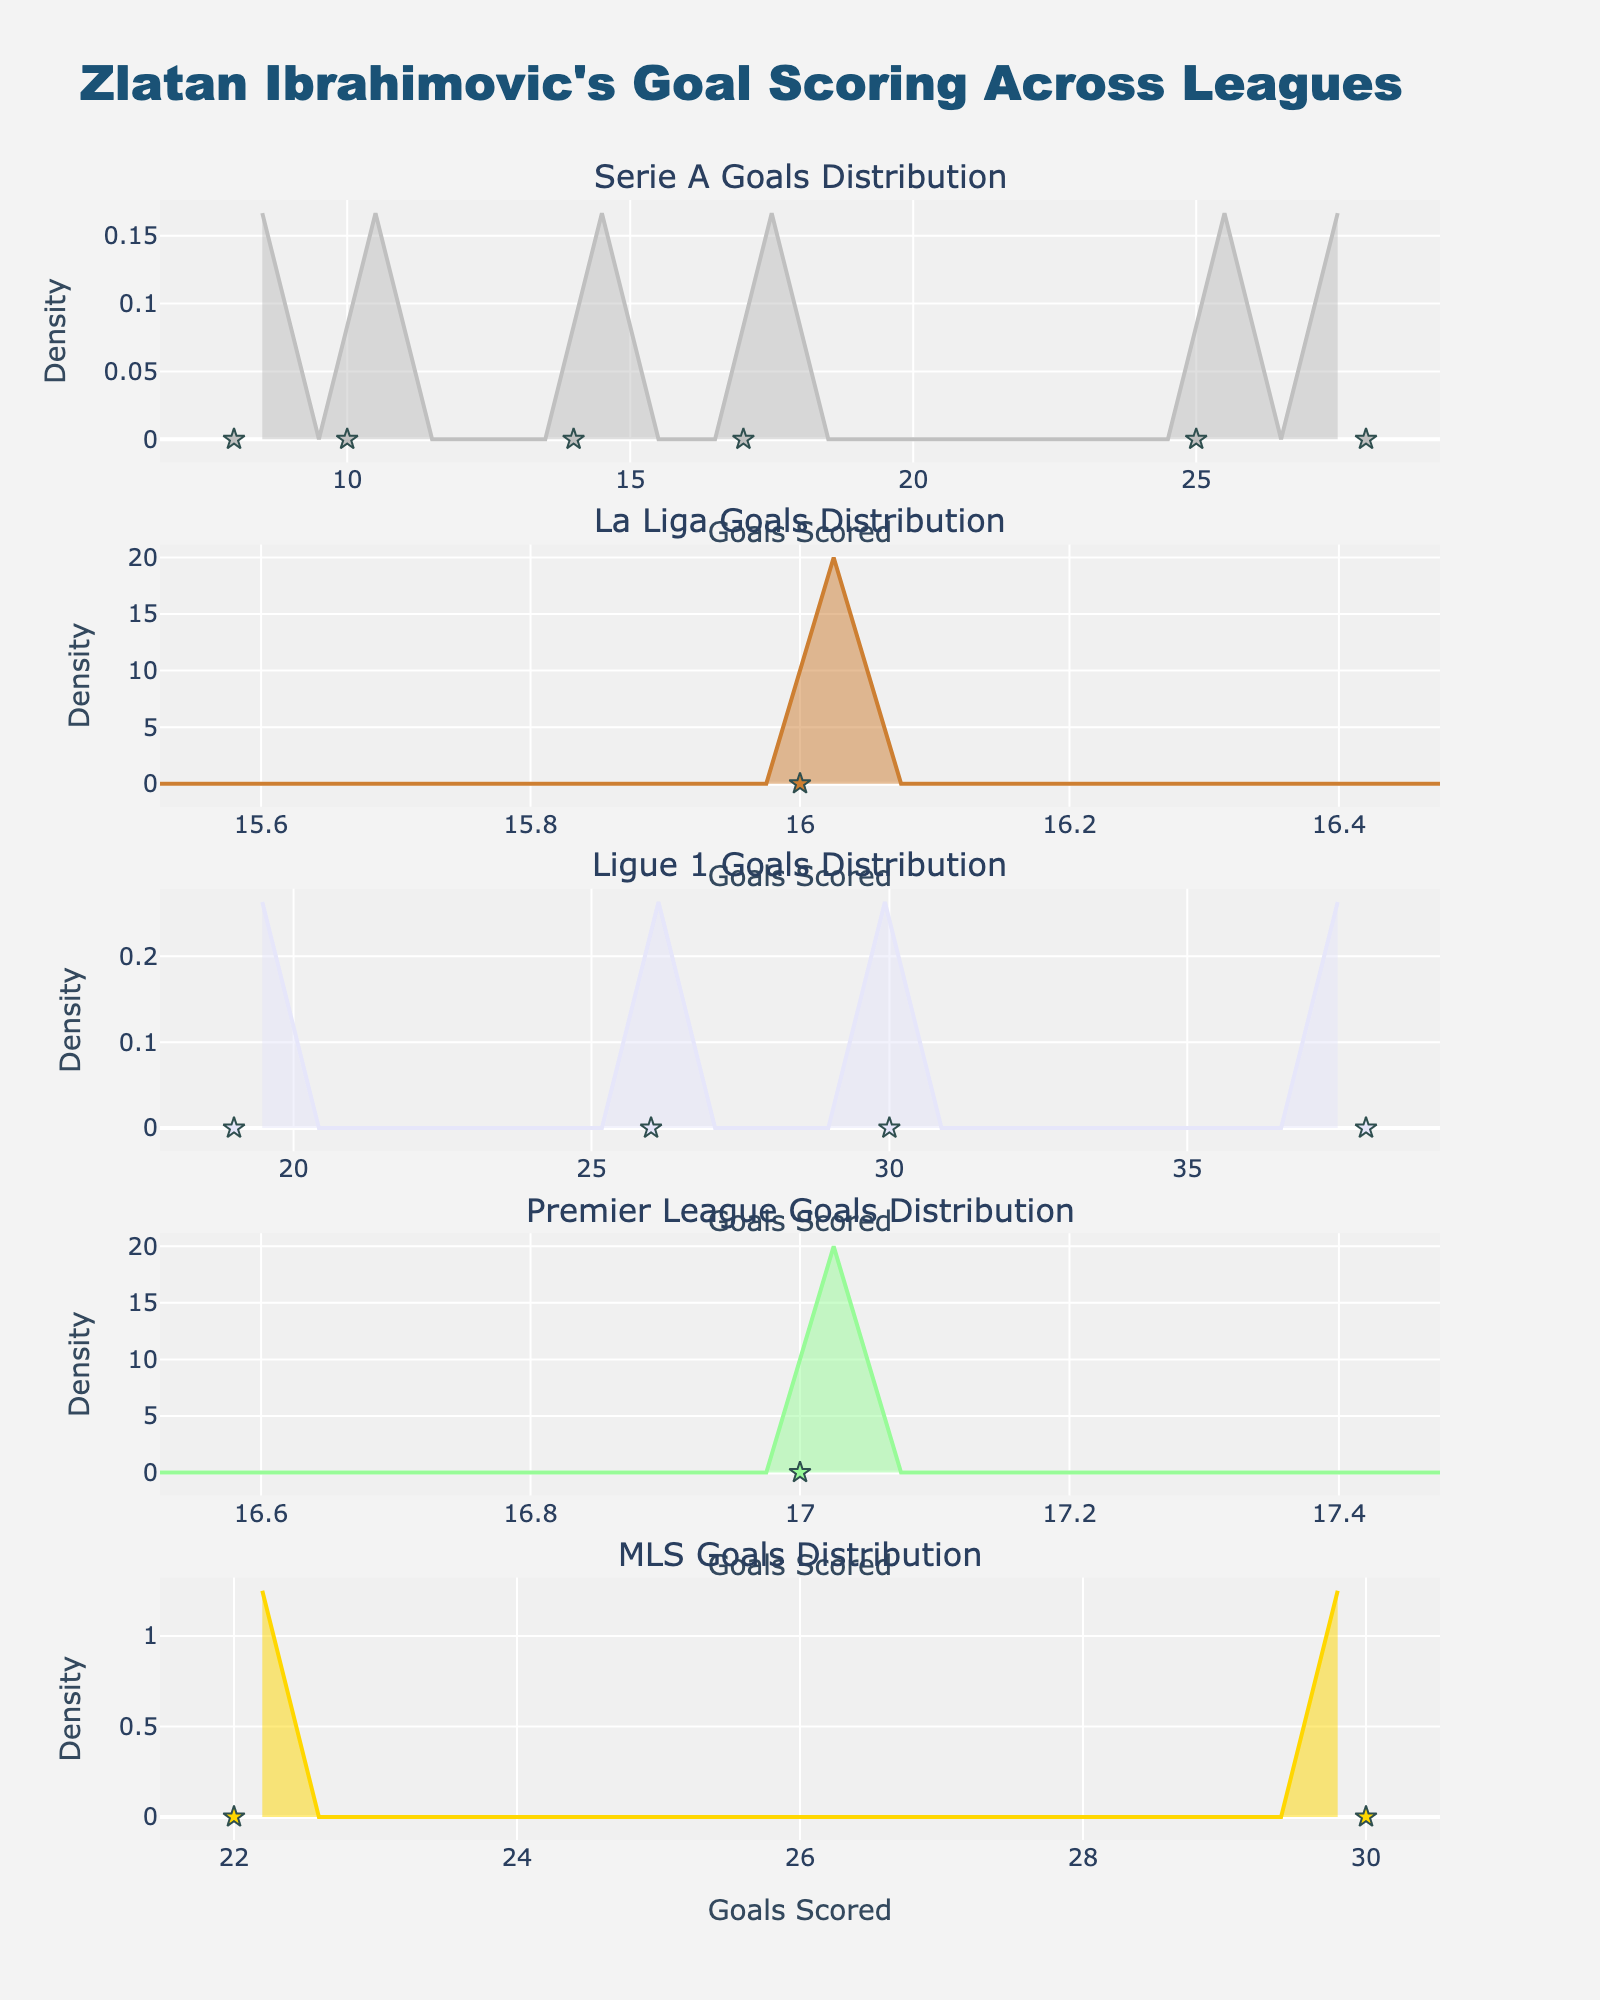What is the title of the plot? The title of the plot is located at the top of the figure and describes the overall content of the plot. It helps viewers understand what the visualization is about.
Answer: Zlatan Ibrahimovic's Goal Scoring Across Leagues How many subplots are there in the figure? By counting the number of separate sections with their own titles and plots, you can determine the number of subplots.
Answer: 5 What is the x-axis labeled as in this figure? The x-axis label is mentioned below each subplot and gives information on what the horizontal axis represents.
Answer: Goals Scored Which league has the highest density peak? The league with the highest density peak will have the tallest point on its KDE (kernel density estimation) line.
Answer: Ligue 1 Which league's subplot has the widest distribution of goals? The league with the widest distribution will have its KDE spread over a larger range of the x-axis, indicating a greater variety of goal counts.
Answer: MLS Between which years did Ibrahimovic score 30 goals in Ligue 1? The scatterplot for Ligue 1 is marked with individual points representing goals scored in different seasons. Checking for points at the 30-goal mark identifies the years.
Answer: 2012-2013, 2015-2016 In which league and season did Ibrahimovic score the fewest goals, according to the plot? Look through the scatter points in each league subplot to find the point closest to the lower end of the x-axis, indicating the fewest goals scored.
Answer: Serie A, 2021-2022 Compare the goal scoring pattern in Serie A and La Liga. By examining both subplots, note the density peaks and the spread of the goals to describe differences in goal-scoring patterns in these leagues.
Answer: Serie A has a broader range with multiple peaks, while La Liga has a single peak and narrower range Which season in the Premier League did Ibrahimovic score 17 goals? The subplot for Premier League will show a single scatter point at the 17-goal mark, which indicates the season.
Answer: 2016-2017 How does the distribution of goals in Serie A compare to Ligue 1? Compare the peaks, spread, and individual points in the KDE plots and scatter points for both Serie A and Ligue 1 subplots to discuss the differences and similarities in goal distributions.
Answer: Serie A has multiple moderate peaks and a wider spread, while Ligue 1 has a sharp peak at higher goals and a more concentrated spread 